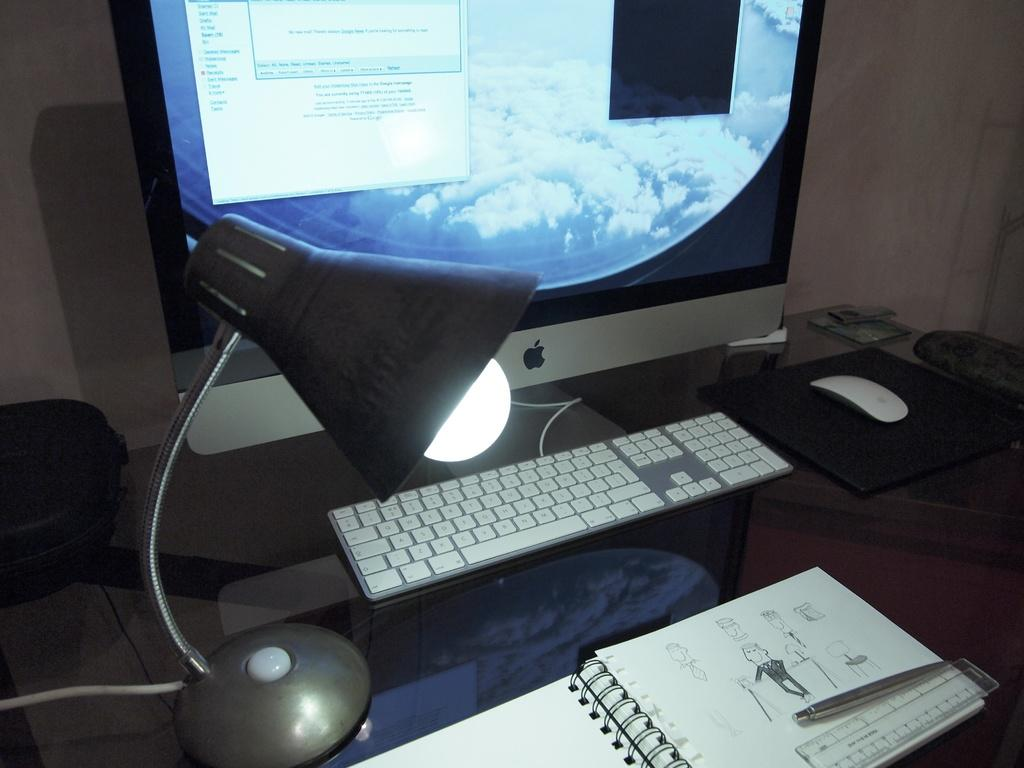<image>
Share a concise interpretation of the image provided. A book of drawings is in front of an apple computer where there is now new mail in the window. 